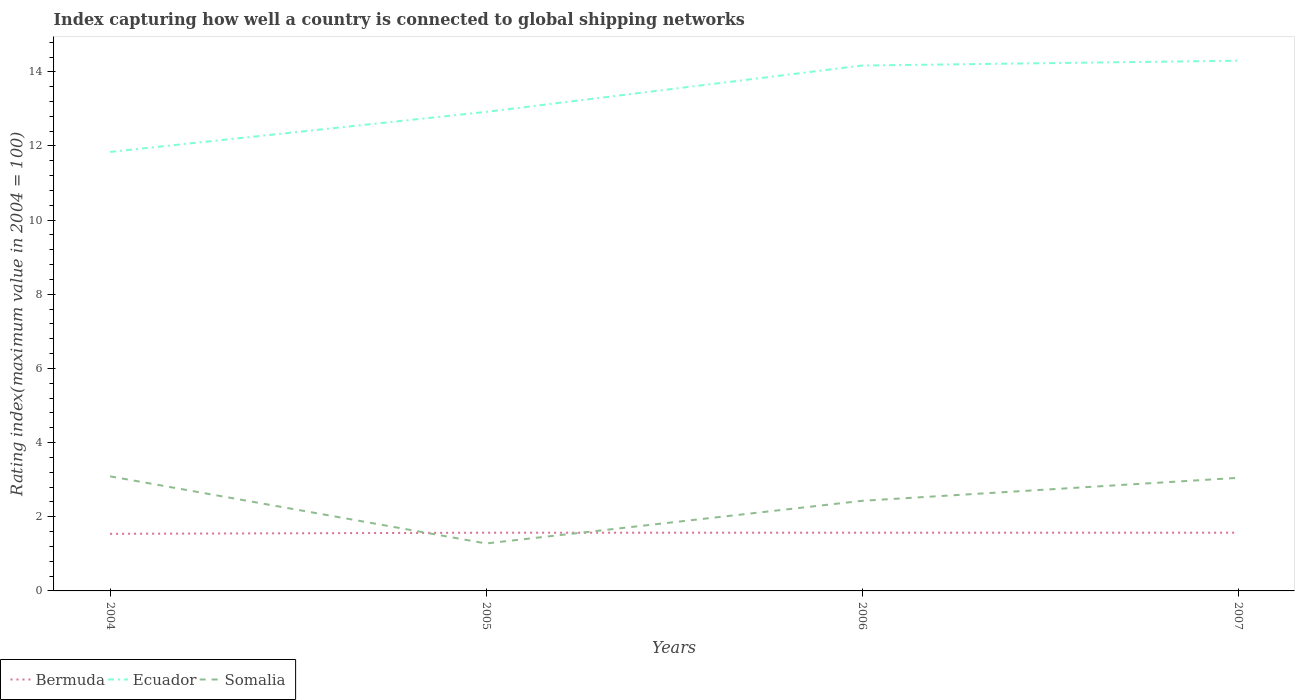Does the line corresponding to Bermuda intersect with the line corresponding to Somalia?
Give a very brief answer. Yes. Is the number of lines equal to the number of legend labels?
Offer a terse response. Yes. Across all years, what is the maximum rating index in Somalia?
Keep it short and to the point. 1.28. What is the total rating index in Somalia in the graph?
Ensure brevity in your answer.  0.66. What is the difference between the highest and the second highest rating index in Bermuda?
Keep it short and to the point. 0.03. What is the difference between the highest and the lowest rating index in Somalia?
Ensure brevity in your answer.  2. How many lines are there?
Your response must be concise. 3. What is the difference between two consecutive major ticks on the Y-axis?
Your response must be concise. 2. Are the values on the major ticks of Y-axis written in scientific E-notation?
Provide a succinct answer. No. Does the graph contain grids?
Ensure brevity in your answer.  No. How are the legend labels stacked?
Your response must be concise. Horizontal. What is the title of the graph?
Give a very brief answer. Index capturing how well a country is connected to global shipping networks. What is the label or title of the Y-axis?
Provide a succinct answer. Rating index(maximum value in 2004 = 100). What is the Rating index(maximum value in 2004 = 100) of Bermuda in 2004?
Provide a succinct answer. 1.54. What is the Rating index(maximum value in 2004 = 100) of Ecuador in 2004?
Your answer should be very brief. 11.84. What is the Rating index(maximum value in 2004 = 100) in Somalia in 2004?
Keep it short and to the point. 3.09. What is the Rating index(maximum value in 2004 = 100) in Bermuda in 2005?
Your answer should be compact. 1.57. What is the Rating index(maximum value in 2004 = 100) of Ecuador in 2005?
Give a very brief answer. 12.92. What is the Rating index(maximum value in 2004 = 100) in Somalia in 2005?
Keep it short and to the point. 1.28. What is the Rating index(maximum value in 2004 = 100) in Bermuda in 2006?
Offer a very short reply. 1.57. What is the Rating index(maximum value in 2004 = 100) in Ecuador in 2006?
Ensure brevity in your answer.  14.17. What is the Rating index(maximum value in 2004 = 100) in Somalia in 2006?
Ensure brevity in your answer.  2.43. What is the Rating index(maximum value in 2004 = 100) of Bermuda in 2007?
Provide a short and direct response. 1.57. What is the Rating index(maximum value in 2004 = 100) of Ecuador in 2007?
Offer a terse response. 14.3. What is the Rating index(maximum value in 2004 = 100) in Somalia in 2007?
Make the answer very short. 3.05. Across all years, what is the maximum Rating index(maximum value in 2004 = 100) in Bermuda?
Provide a succinct answer. 1.57. Across all years, what is the maximum Rating index(maximum value in 2004 = 100) in Ecuador?
Provide a succinct answer. 14.3. Across all years, what is the maximum Rating index(maximum value in 2004 = 100) of Somalia?
Your answer should be very brief. 3.09. Across all years, what is the minimum Rating index(maximum value in 2004 = 100) of Bermuda?
Keep it short and to the point. 1.54. Across all years, what is the minimum Rating index(maximum value in 2004 = 100) in Ecuador?
Offer a terse response. 11.84. Across all years, what is the minimum Rating index(maximum value in 2004 = 100) of Somalia?
Your response must be concise. 1.28. What is the total Rating index(maximum value in 2004 = 100) in Bermuda in the graph?
Provide a succinct answer. 6.25. What is the total Rating index(maximum value in 2004 = 100) in Ecuador in the graph?
Offer a terse response. 53.23. What is the total Rating index(maximum value in 2004 = 100) of Somalia in the graph?
Offer a very short reply. 9.85. What is the difference between the Rating index(maximum value in 2004 = 100) of Bermuda in 2004 and that in 2005?
Give a very brief answer. -0.03. What is the difference between the Rating index(maximum value in 2004 = 100) in Ecuador in 2004 and that in 2005?
Offer a very short reply. -1.08. What is the difference between the Rating index(maximum value in 2004 = 100) of Somalia in 2004 and that in 2005?
Your response must be concise. 1.81. What is the difference between the Rating index(maximum value in 2004 = 100) in Bermuda in 2004 and that in 2006?
Your answer should be very brief. -0.03. What is the difference between the Rating index(maximum value in 2004 = 100) in Ecuador in 2004 and that in 2006?
Make the answer very short. -2.33. What is the difference between the Rating index(maximum value in 2004 = 100) of Somalia in 2004 and that in 2006?
Keep it short and to the point. 0.66. What is the difference between the Rating index(maximum value in 2004 = 100) in Bermuda in 2004 and that in 2007?
Ensure brevity in your answer.  -0.03. What is the difference between the Rating index(maximum value in 2004 = 100) in Ecuador in 2004 and that in 2007?
Offer a very short reply. -2.46. What is the difference between the Rating index(maximum value in 2004 = 100) of Somalia in 2004 and that in 2007?
Ensure brevity in your answer.  0.04. What is the difference between the Rating index(maximum value in 2004 = 100) in Bermuda in 2005 and that in 2006?
Provide a succinct answer. 0. What is the difference between the Rating index(maximum value in 2004 = 100) in Ecuador in 2005 and that in 2006?
Provide a short and direct response. -1.25. What is the difference between the Rating index(maximum value in 2004 = 100) of Somalia in 2005 and that in 2006?
Provide a short and direct response. -1.15. What is the difference between the Rating index(maximum value in 2004 = 100) in Ecuador in 2005 and that in 2007?
Your answer should be very brief. -1.38. What is the difference between the Rating index(maximum value in 2004 = 100) of Somalia in 2005 and that in 2007?
Provide a succinct answer. -1.77. What is the difference between the Rating index(maximum value in 2004 = 100) of Bermuda in 2006 and that in 2007?
Your answer should be very brief. 0. What is the difference between the Rating index(maximum value in 2004 = 100) of Ecuador in 2006 and that in 2007?
Your answer should be very brief. -0.13. What is the difference between the Rating index(maximum value in 2004 = 100) of Somalia in 2006 and that in 2007?
Make the answer very short. -0.62. What is the difference between the Rating index(maximum value in 2004 = 100) in Bermuda in 2004 and the Rating index(maximum value in 2004 = 100) in Ecuador in 2005?
Your response must be concise. -11.38. What is the difference between the Rating index(maximum value in 2004 = 100) of Bermuda in 2004 and the Rating index(maximum value in 2004 = 100) of Somalia in 2005?
Make the answer very short. 0.26. What is the difference between the Rating index(maximum value in 2004 = 100) of Ecuador in 2004 and the Rating index(maximum value in 2004 = 100) of Somalia in 2005?
Your answer should be compact. 10.56. What is the difference between the Rating index(maximum value in 2004 = 100) in Bermuda in 2004 and the Rating index(maximum value in 2004 = 100) in Ecuador in 2006?
Offer a terse response. -12.63. What is the difference between the Rating index(maximum value in 2004 = 100) in Bermuda in 2004 and the Rating index(maximum value in 2004 = 100) in Somalia in 2006?
Your answer should be compact. -0.89. What is the difference between the Rating index(maximum value in 2004 = 100) in Ecuador in 2004 and the Rating index(maximum value in 2004 = 100) in Somalia in 2006?
Your answer should be compact. 9.41. What is the difference between the Rating index(maximum value in 2004 = 100) in Bermuda in 2004 and the Rating index(maximum value in 2004 = 100) in Ecuador in 2007?
Your answer should be very brief. -12.76. What is the difference between the Rating index(maximum value in 2004 = 100) of Bermuda in 2004 and the Rating index(maximum value in 2004 = 100) of Somalia in 2007?
Provide a short and direct response. -1.51. What is the difference between the Rating index(maximum value in 2004 = 100) in Ecuador in 2004 and the Rating index(maximum value in 2004 = 100) in Somalia in 2007?
Your response must be concise. 8.79. What is the difference between the Rating index(maximum value in 2004 = 100) in Bermuda in 2005 and the Rating index(maximum value in 2004 = 100) in Ecuador in 2006?
Give a very brief answer. -12.6. What is the difference between the Rating index(maximum value in 2004 = 100) in Bermuda in 2005 and the Rating index(maximum value in 2004 = 100) in Somalia in 2006?
Make the answer very short. -0.86. What is the difference between the Rating index(maximum value in 2004 = 100) in Ecuador in 2005 and the Rating index(maximum value in 2004 = 100) in Somalia in 2006?
Make the answer very short. 10.49. What is the difference between the Rating index(maximum value in 2004 = 100) of Bermuda in 2005 and the Rating index(maximum value in 2004 = 100) of Ecuador in 2007?
Provide a succinct answer. -12.73. What is the difference between the Rating index(maximum value in 2004 = 100) of Bermuda in 2005 and the Rating index(maximum value in 2004 = 100) of Somalia in 2007?
Provide a short and direct response. -1.48. What is the difference between the Rating index(maximum value in 2004 = 100) in Ecuador in 2005 and the Rating index(maximum value in 2004 = 100) in Somalia in 2007?
Ensure brevity in your answer.  9.87. What is the difference between the Rating index(maximum value in 2004 = 100) of Bermuda in 2006 and the Rating index(maximum value in 2004 = 100) of Ecuador in 2007?
Your answer should be very brief. -12.73. What is the difference between the Rating index(maximum value in 2004 = 100) of Bermuda in 2006 and the Rating index(maximum value in 2004 = 100) of Somalia in 2007?
Give a very brief answer. -1.48. What is the difference between the Rating index(maximum value in 2004 = 100) of Ecuador in 2006 and the Rating index(maximum value in 2004 = 100) of Somalia in 2007?
Ensure brevity in your answer.  11.12. What is the average Rating index(maximum value in 2004 = 100) of Bermuda per year?
Provide a succinct answer. 1.56. What is the average Rating index(maximum value in 2004 = 100) of Ecuador per year?
Your answer should be very brief. 13.31. What is the average Rating index(maximum value in 2004 = 100) of Somalia per year?
Ensure brevity in your answer.  2.46. In the year 2004, what is the difference between the Rating index(maximum value in 2004 = 100) in Bermuda and Rating index(maximum value in 2004 = 100) in Somalia?
Your answer should be very brief. -1.55. In the year 2004, what is the difference between the Rating index(maximum value in 2004 = 100) of Ecuador and Rating index(maximum value in 2004 = 100) of Somalia?
Provide a short and direct response. 8.75. In the year 2005, what is the difference between the Rating index(maximum value in 2004 = 100) of Bermuda and Rating index(maximum value in 2004 = 100) of Ecuador?
Make the answer very short. -11.35. In the year 2005, what is the difference between the Rating index(maximum value in 2004 = 100) of Bermuda and Rating index(maximum value in 2004 = 100) of Somalia?
Offer a terse response. 0.29. In the year 2005, what is the difference between the Rating index(maximum value in 2004 = 100) in Ecuador and Rating index(maximum value in 2004 = 100) in Somalia?
Offer a very short reply. 11.64. In the year 2006, what is the difference between the Rating index(maximum value in 2004 = 100) of Bermuda and Rating index(maximum value in 2004 = 100) of Somalia?
Offer a terse response. -0.86. In the year 2006, what is the difference between the Rating index(maximum value in 2004 = 100) of Ecuador and Rating index(maximum value in 2004 = 100) of Somalia?
Ensure brevity in your answer.  11.74. In the year 2007, what is the difference between the Rating index(maximum value in 2004 = 100) in Bermuda and Rating index(maximum value in 2004 = 100) in Ecuador?
Provide a short and direct response. -12.73. In the year 2007, what is the difference between the Rating index(maximum value in 2004 = 100) in Bermuda and Rating index(maximum value in 2004 = 100) in Somalia?
Your answer should be compact. -1.48. In the year 2007, what is the difference between the Rating index(maximum value in 2004 = 100) in Ecuador and Rating index(maximum value in 2004 = 100) in Somalia?
Provide a succinct answer. 11.25. What is the ratio of the Rating index(maximum value in 2004 = 100) of Bermuda in 2004 to that in 2005?
Your response must be concise. 0.98. What is the ratio of the Rating index(maximum value in 2004 = 100) in Ecuador in 2004 to that in 2005?
Provide a short and direct response. 0.92. What is the ratio of the Rating index(maximum value in 2004 = 100) in Somalia in 2004 to that in 2005?
Your response must be concise. 2.41. What is the ratio of the Rating index(maximum value in 2004 = 100) in Bermuda in 2004 to that in 2006?
Your answer should be very brief. 0.98. What is the ratio of the Rating index(maximum value in 2004 = 100) in Ecuador in 2004 to that in 2006?
Your answer should be compact. 0.84. What is the ratio of the Rating index(maximum value in 2004 = 100) in Somalia in 2004 to that in 2006?
Provide a succinct answer. 1.27. What is the ratio of the Rating index(maximum value in 2004 = 100) in Bermuda in 2004 to that in 2007?
Your response must be concise. 0.98. What is the ratio of the Rating index(maximum value in 2004 = 100) of Ecuador in 2004 to that in 2007?
Offer a terse response. 0.83. What is the ratio of the Rating index(maximum value in 2004 = 100) of Somalia in 2004 to that in 2007?
Provide a succinct answer. 1.01. What is the ratio of the Rating index(maximum value in 2004 = 100) in Bermuda in 2005 to that in 2006?
Make the answer very short. 1. What is the ratio of the Rating index(maximum value in 2004 = 100) of Ecuador in 2005 to that in 2006?
Offer a very short reply. 0.91. What is the ratio of the Rating index(maximum value in 2004 = 100) of Somalia in 2005 to that in 2006?
Offer a terse response. 0.53. What is the ratio of the Rating index(maximum value in 2004 = 100) of Bermuda in 2005 to that in 2007?
Provide a short and direct response. 1. What is the ratio of the Rating index(maximum value in 2004 = 100) in Ecuador in 2005 to that in 2007?
Offer a terse response. 0.9. What is the ratio of the Rating index(maximum value in 2004 = 100) in Somalia in 2005 to that in 2007?
Provide a succinct answer. 0.42. What is the ratio of the Rating index(maximum value in 2004 = 100) of Bermuda in 2006 to that in 2007?
Ensure brevity in your answer.  1. What is the ratio of the Rating index(maximum value in 2004 = 100) in Ecuador in 2006 to that in 2007?
Offer a very short reply. 0.99. What is the ratio of the Rating index(maximum value in 2004 = 100) in Somalia in 2006 to that in 2007?
Your answer should be compact. 0.8. What is the difference between the highest and the second highest Rating index(maximum value in 2004 = 100) in Bermuda?
Keep it short and to the point. 0. What is the difference between the highest and the second highest Rating index(maximum value in 2004 = 100) in Ecuador?
Ensure brevity in your answer.  0.13. What is the difference between the highest and the second highest Rating index(maximum value in 2004 = 100) in Somalia?
Offer a terse response. 0.04. What is the difference between the highest and the lowest Rating index(maximum value in 2004 = 100) in Ecuador?
Provide a short and direct response. 2.46. What is the difference between the highest and the lowest Rating index(maximum value in 2004 = 100) of Somalia?
Make the answer very short. 1.81. 